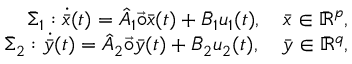Convert formula to latex. <formula><loc_0><loc_0><loc_500><loc_500>\begin{array} { r } { \bar { \Sigma } _ { 1 } \colon \dot { \bar { x } } ( t ) = \hat { A } _ { 1 } \vec { \circ } \bar { x } ( t ) + \bar { B } _ { 1 } u _ { 1 } ( t ) , \quad \bar { x } \in \bar { \mathbb { R } } ^ { p } , } \\ { \bar { \Sigma } _ { 2 } \colon \dot { \bar { y } } ( t ) = \hat { A } _ { 2 } \vec { \circ } \bar { y } ( t ) + \bar { B } _ { 2 } u _ { 2 } ( t ) , \quad \bar { y } \in \bar { \mathbb { R } } ^ { q } , } \end{array}</formula> 